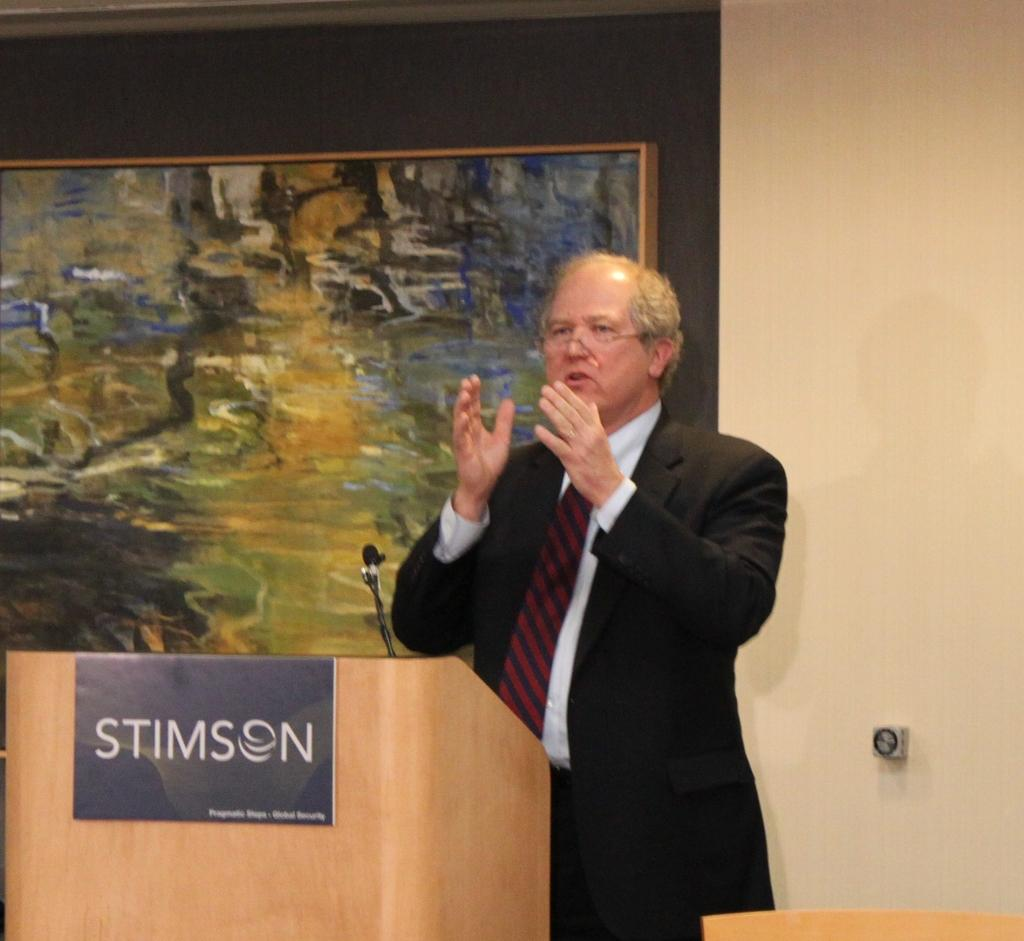What is the main subject of the image? The main subject of the image is a man standing. Can you describe the man's appearance? The man is wearing clothes and spectacles. What is the man doing in the image? The man is talking. What objects are present in the image related to the man's activity? There is a podium and a microphone in the image. Are there any other objects or elements in the image? Yes, there is a photo frame, a poster, and a wall in the image. What type of board is the man standing on in the image? There is no board present in the image; the man is standing near a wall with a podium and a microphone. Is the man performing on a stage in the image? There is no stage present in the image; the man is standing near a wall with a podium and a microphone. 